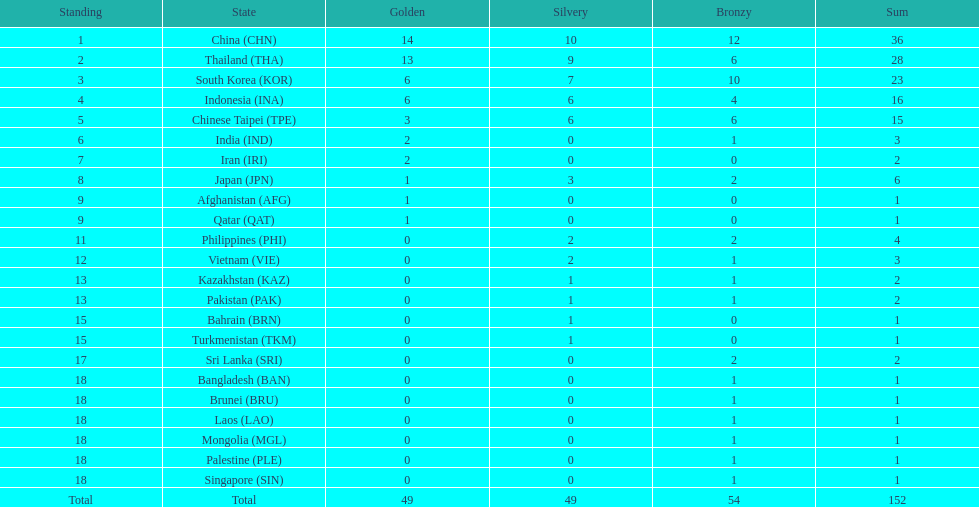Which nation finished first in total medals earned? China (CHN). 